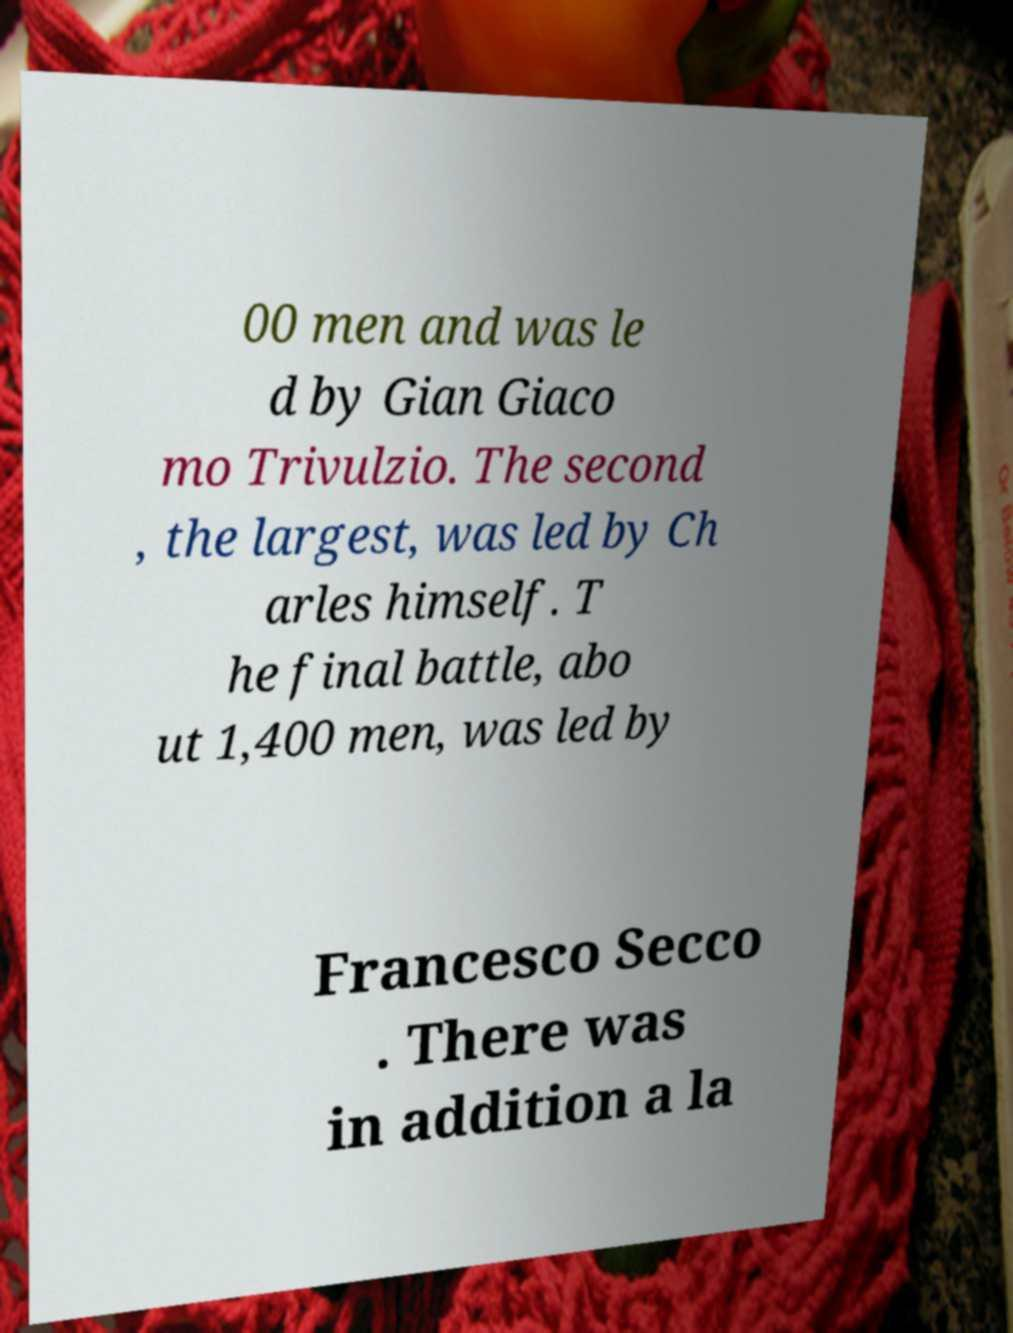Please read and relay the text visible in this image. What does it say? 00 men and was le d by Gian Giaco mo Trivulzio. The second , the largest, was led by Ch arles himself. T he final battle, abo ut 1,400 men, was led by Francesco Secco . There was in addition a la 